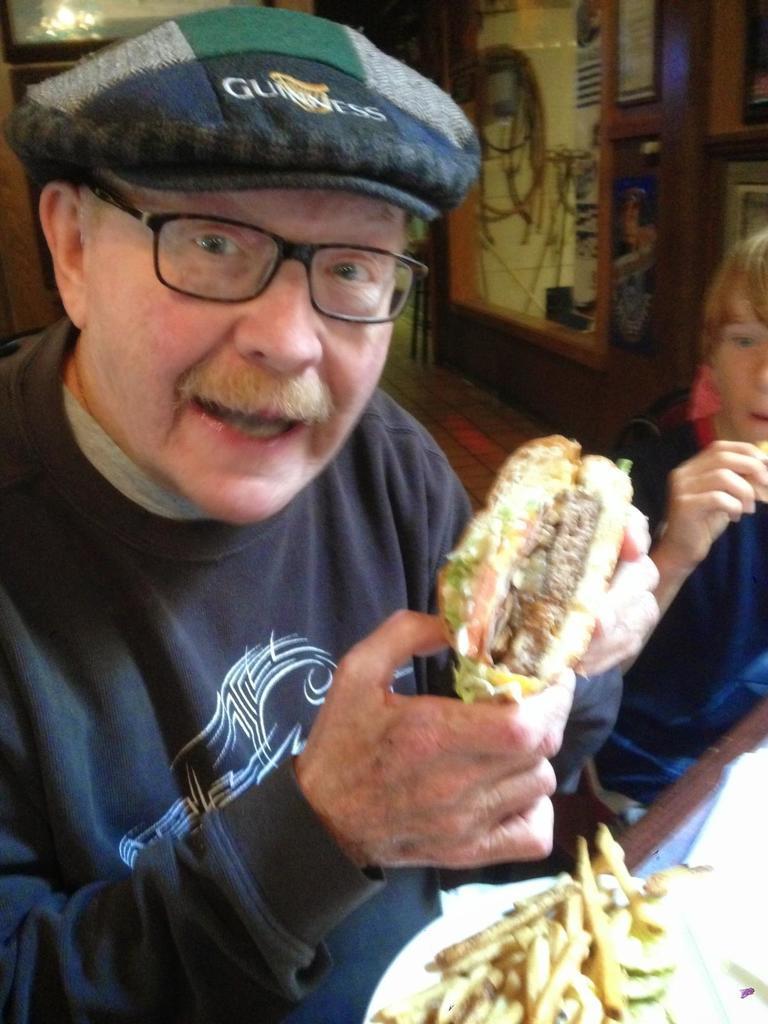Describe this image in one or two sentences. In the center of the image there is a person holding a burger. There is a french fry plate. Beside him there is a boy. In the background of the image there is a wooden wall. 